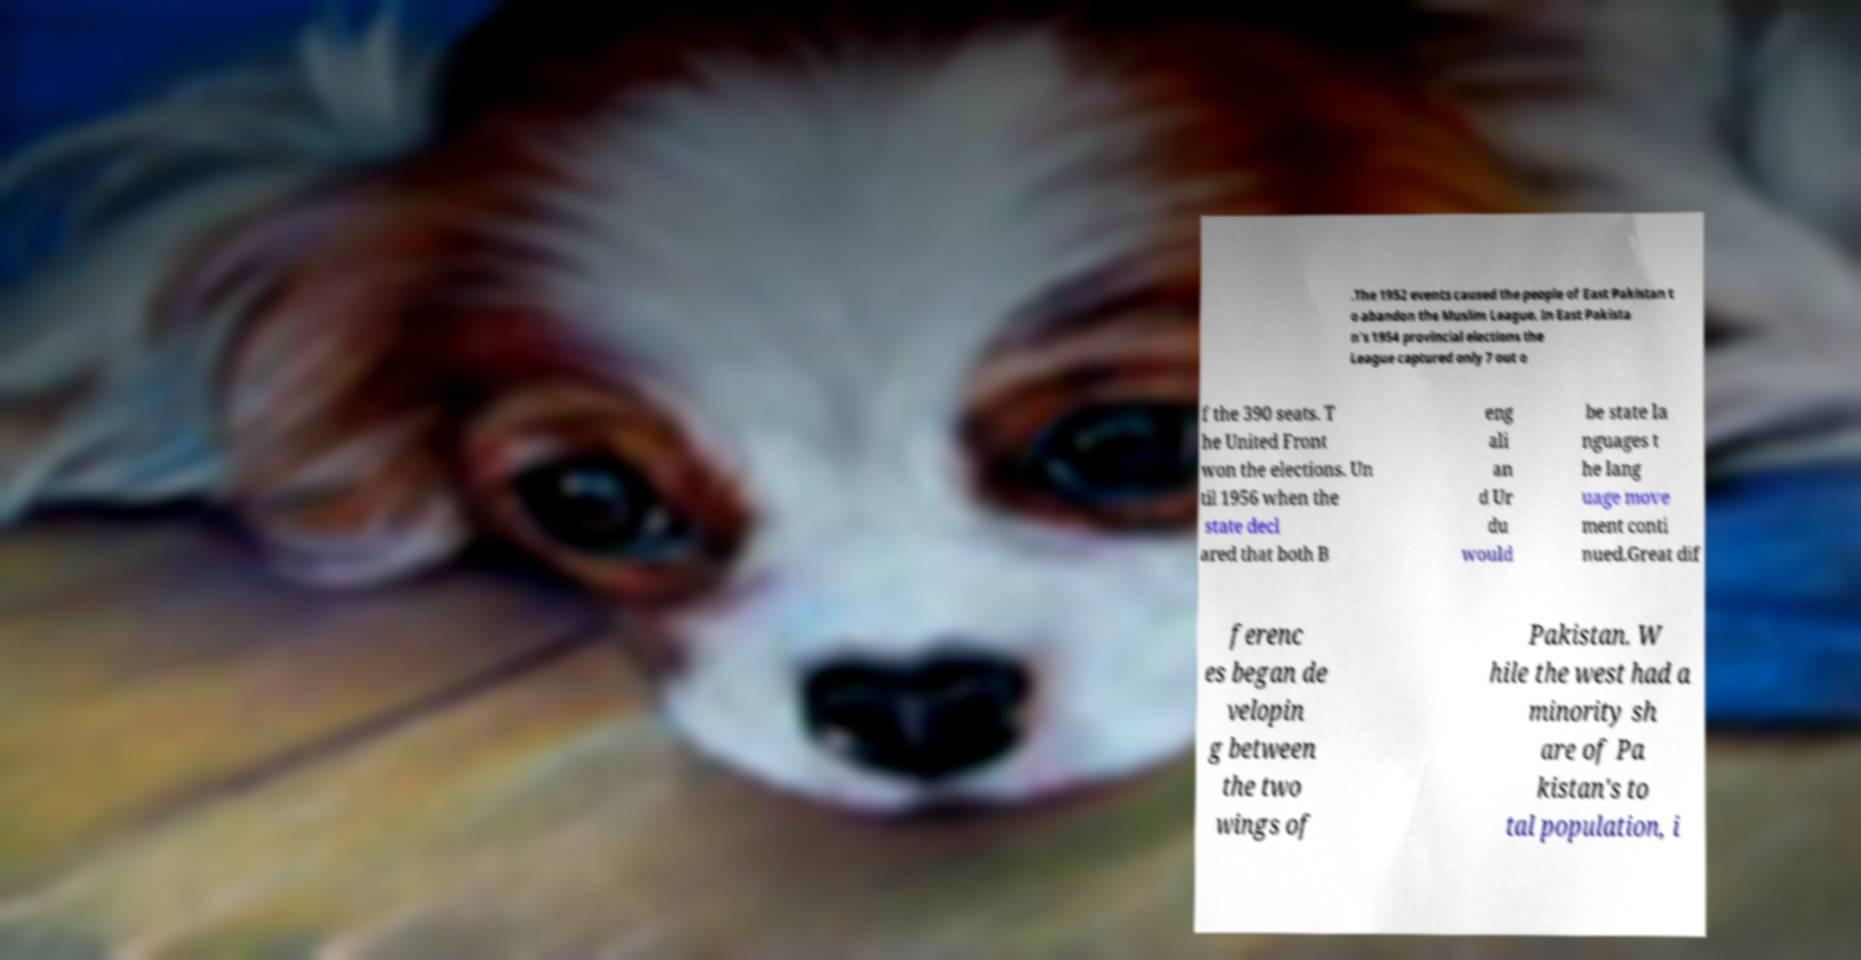For documentation purposes, I need the text within this image transcribed. Could you provide that? .The 1952 events caused the people of East Pakistan t o abandon the Muslim League. In East Pakista n's 1954 provincial elections the League captured only 7 out o f the 390 seats. T he United Front won the elections. Un til 1956 when the state decl ared that both B eng ali an d Ur du would be state la nguages t he lang uage move ment conti nued.Great dif ferenc es began de velopin g between the two wings of Pakistan. W hile the west had a minority sh are of Pa kistan's to tal population, i 